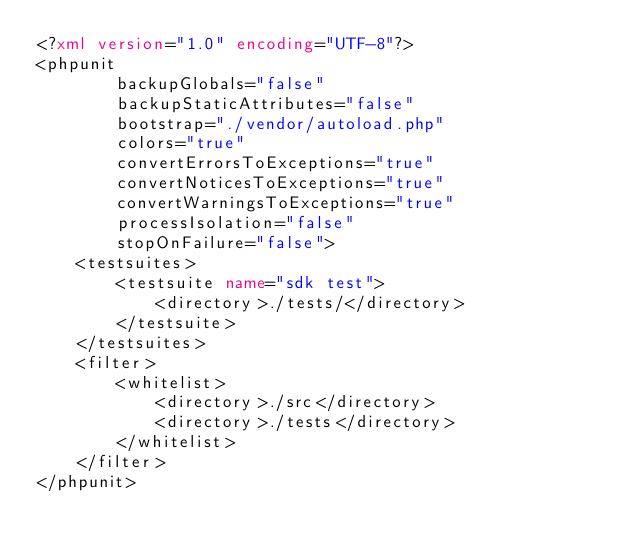<code> <loc_0><loc_0><loc_500><loc_500><_XML_><?xml version="1.0" encoding="UTF-8"?>
<phpunit
        backupGlobals="false"
        backupStaticAttributes="false"
        bootstrap="./vendor/autoload.php"
        colors="true"
        convertErrorsToExceptions="true"
        convertNoticesToExceptions="true"
        convertWarningsToExceptions="true"
        processIsolation="false"
        stopOnFailure="false">
    <testsuites>
        <testsuite name="sdk test">
            <directory>./tests/</directory>
        </testsuite>
    </testsuites>
    <filter>
        <whitelist>
            <directory>./src</directory>
            <directory>./tests</directory>
        </whitelist>
    </filter>
</phpunit></code> 